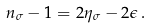Convert formula to latex. <formula><loc_0><loc_0><loc_500><loc_500>n _ { \sigma } - 1 = 2 \eta _ { \sigma } - 2 \epsilon \, .</formula> 